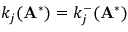<formula> <loc_0><loc_0><loc_500><loc_500>k _ { j } ( A ^ { * } ) = k _ { j } ^ { - } ( A ^ { * } )</formula> 